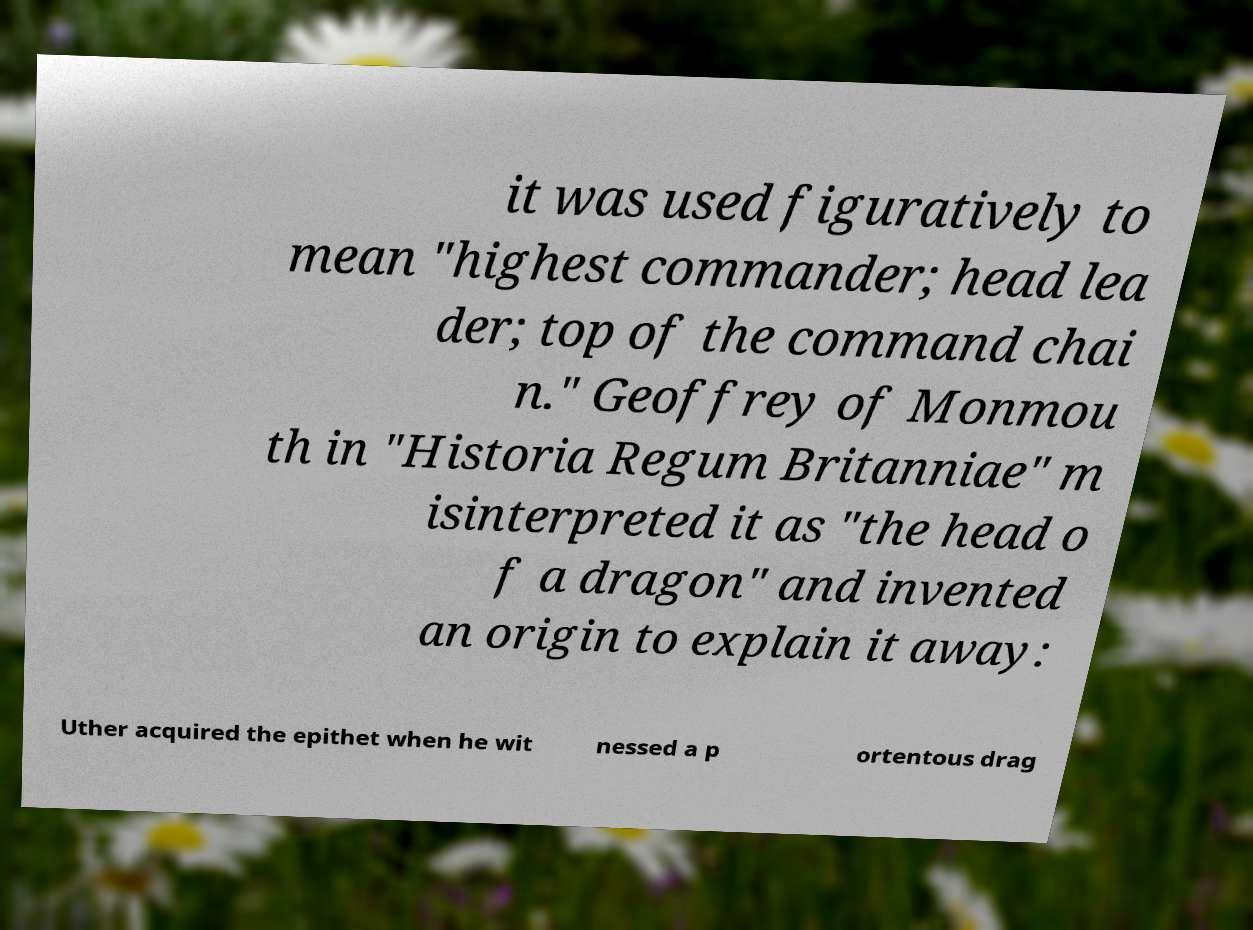I need the written content from this picture converted into text. Can you do that? it was used figuratively to mean "highest commander; head lea der; top of the command chai n." Geoffrey of Monmou th in "Historia Regum Britanniae" m isinterpreted it as "the head o f a dragon" and invented an origin to explain it away: Uther acquired the epithet when he wit nessed a p ortentous drag 